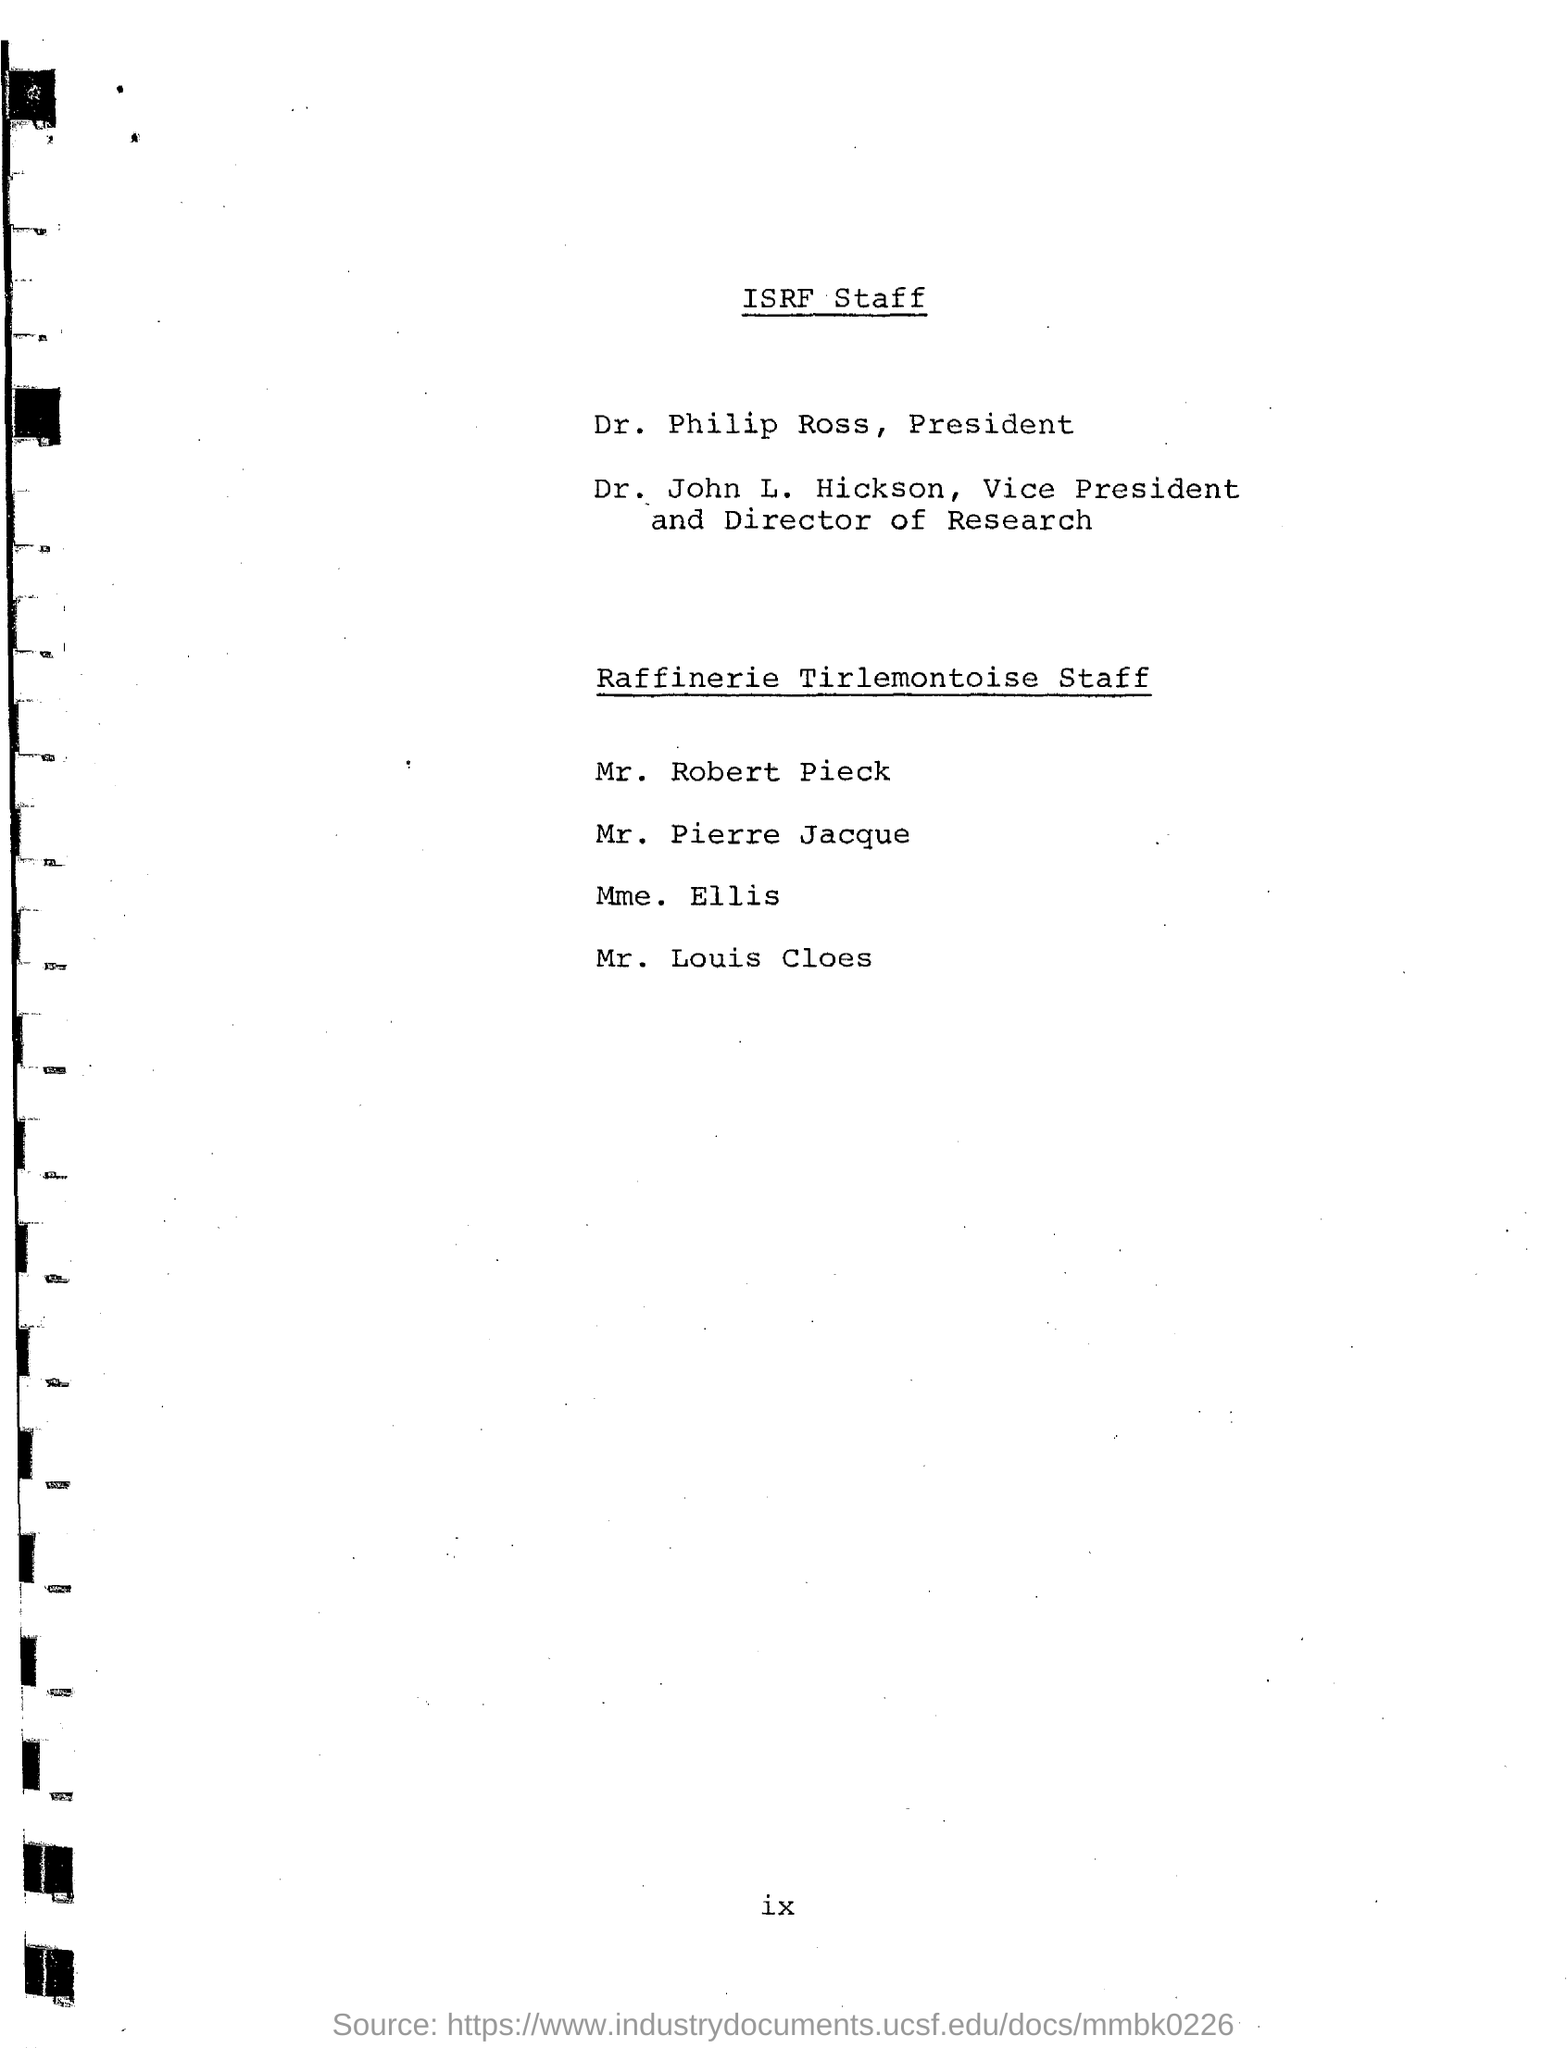Who is the President?
Your response must be concise. DR. PHILIP ROSS. Who is the Vice President and Director of Research?
Keep it short and to the point. DR. JOHN L. HICKSON. 